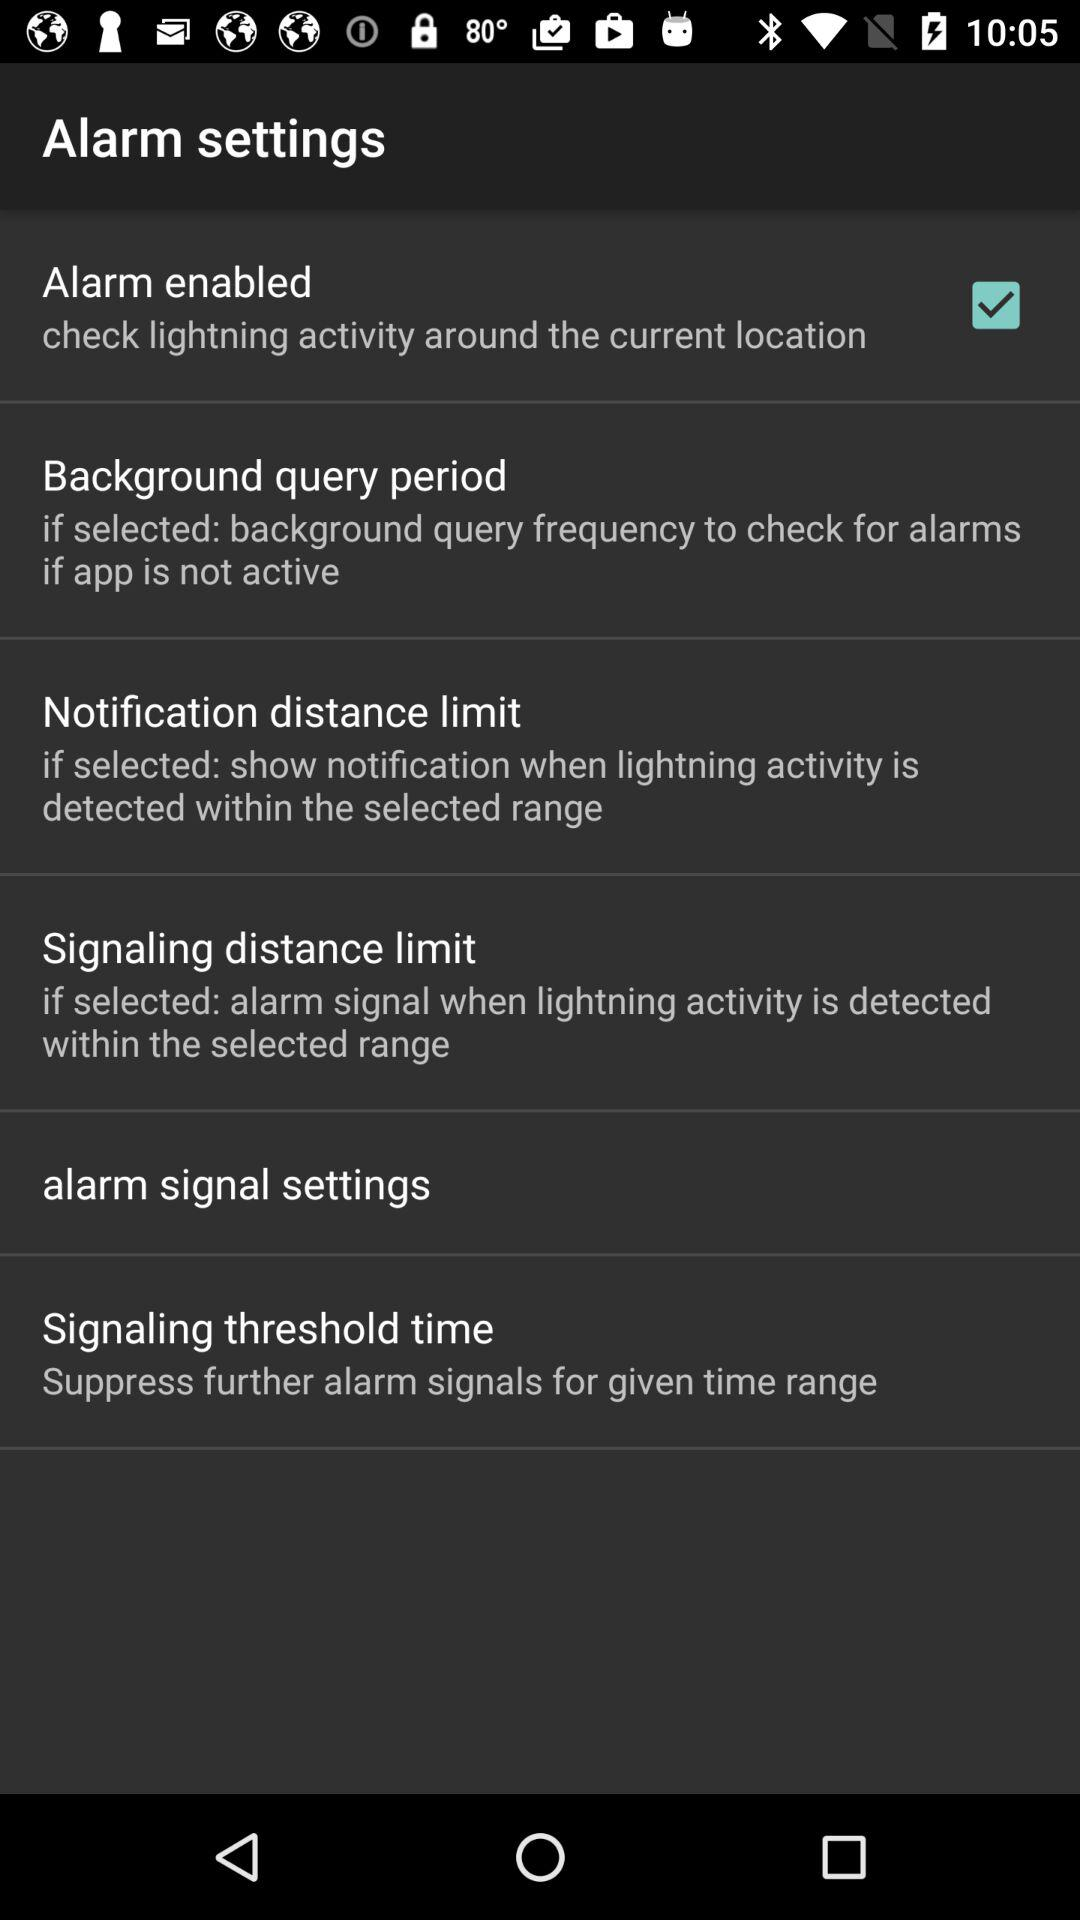When do we see the notification for the distance limit? You see the notification for the distance limit when lightning activity is detected within the selected range. 